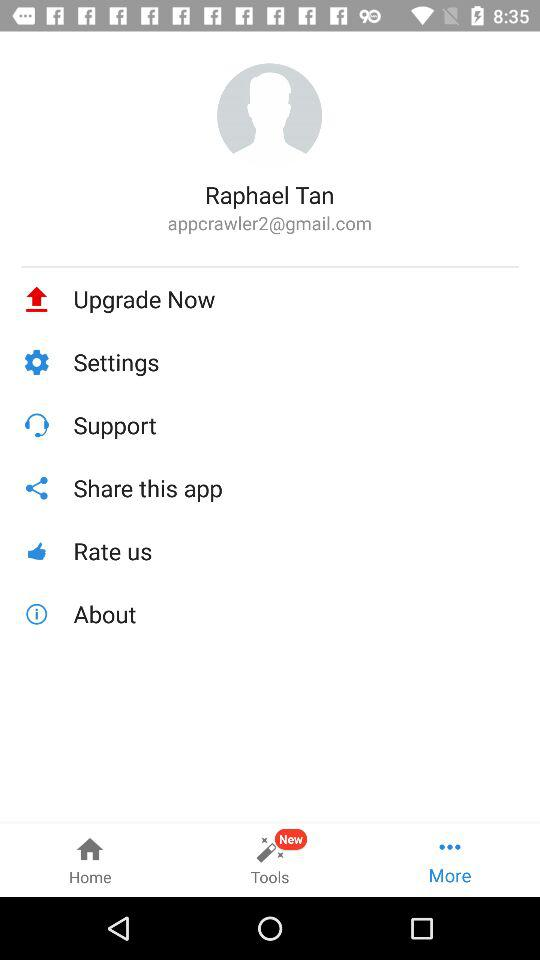What is the user name? The user name is Raphael Tan. 